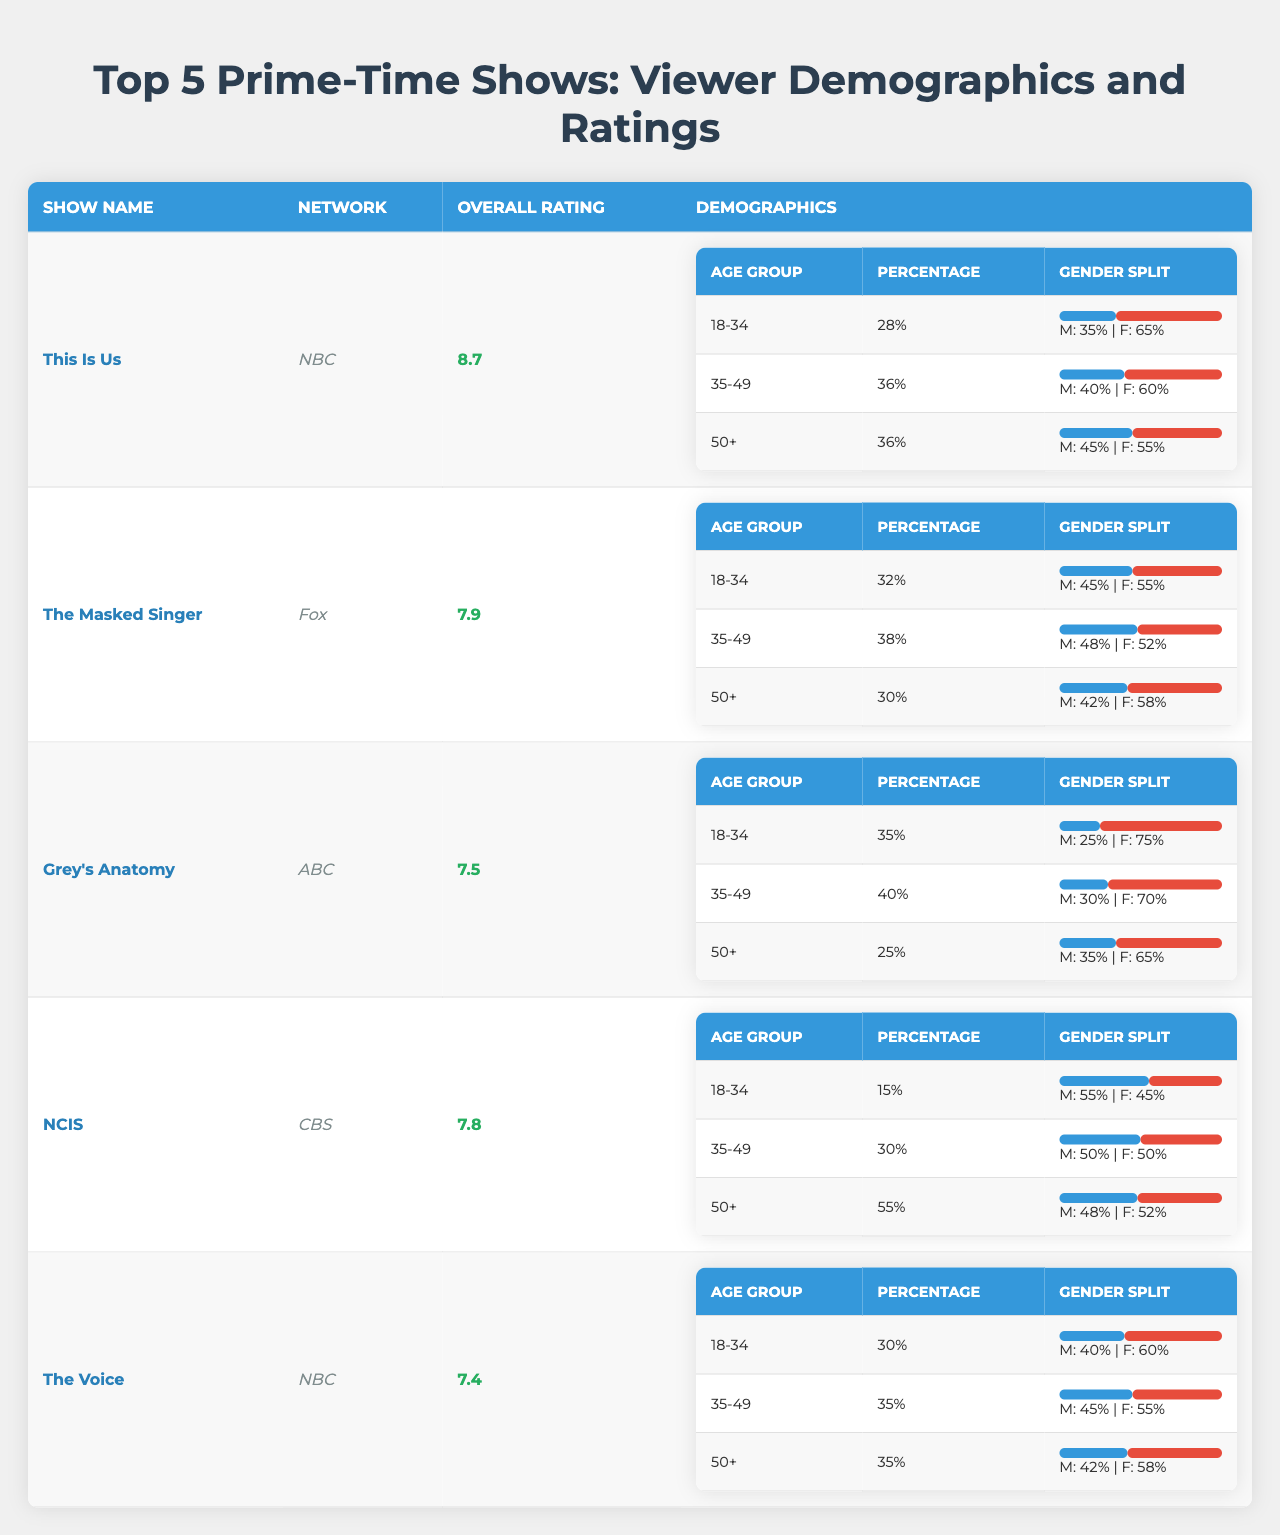What is the overall rating for "This Is Us"? The table indicates that the overall rating for "This Is Us" is listed directly next to its show name. Looking at the data, it shows an overall rating of 8.7.
Answer: 8.7 Which show has the highest percentage of viewers in the 18-34 age group? By comparing the percentages from the demographic breakdown for each show, "Grey's Anatomy" has the highest percentage at 35%.
Answer: "Grey's Anatomy" What is the gender split percentage for the 35-49 age group in "The Masked Singer"? The gender split for the 35-49 age group is found in the demographic section for "The Masked Singer." It shows that the split is 48% male and 52% female.
Answer: M: 48%, F: 52% Is "NCIS" more popular with males or females in the 50+ age group? Looking at the gender split for the 50+ age group in "NCIS", it shows a percentage of 48% male and 52% female. Since the female percentage is higher, this indicates it is more popular with females.
Answer: Females What is the average overall rating of the top 5 shows? To find the average rating, first, sum the overall ratings: 8.7 + 7.9 + 7.5 + 7.8 + 7.4 = 39.3. Then divide by the total number of shows (5): 39.3 / 5 = 7.86.
Answer: 7.86 In which show is the 50+ age group the largest demographic percentage? By extracting the percentage for the 50+ age group from each show, "NCIS" has the largest percentage at 55%.
Answer: "NCIS" How does the gender split change in the 18-34 age group between "The Voice" and "This Is Us"? For "The Voice," the gender split is 40% male and 60% female, while for "This Is Us," the split is 35% male and 65% female, meaning "The Voice" has a slightly higher male viewership.
Answer: The Voice has a higher male viewership Which show has a lower male representation in the 50+ age group, "Grey's Anatomy" or "NCIS"? Comparing the male percentages for the 50+ age group, "Grey's Anatomy" has 35% while "NCIS" has 48%. Therefore, "Grey's Anatomy" has lower male representation.
Answer: "Grey's Anatomy" What percentage of "This Is Us" viewers are in the 35-49 age group? From the table, "This Is Us" has 36% of viewers in the 35-49 age group, as directly stated in the demographic breakdown.
Answer: 36% Summarize the gender split for the 50+ age group across all 5 shows. The gender splits for the 50+ age group are as follows: "This Is Us" - 45% Male / 55% Female, "The Masked Singer" - 42% Male / 58% Female, "Grey's Anatomy" - 35% Male / 65% Female, "NCIS" - 48% Male / 52% Female, "The Voice" - 42% Male / 58% Female. This shows a trend of more females in all shows.
Answer: More females overall 